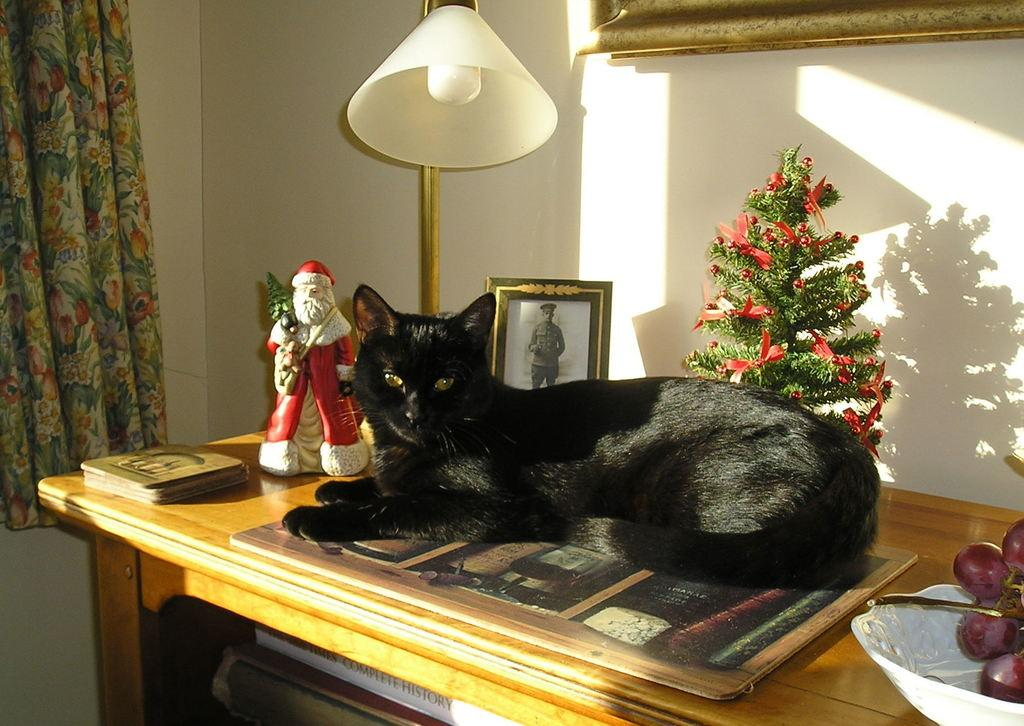What is located in the center of the room in the image? There is a table in the center of the room in the image. What can be seen on top of the table? There is a cat, a Christmas tree, a statue, a bowl, and grapes on the table. What is visible in the background of the image? There is a wall, a curtain, a lamp, and a photo frame in the background. How many trees are there in the image? There is no tree present in the image; only a Christmas tree on the table. What type of twig is the cat holding in the image? There is no twig present in the image, and the cat is not holding anything. 